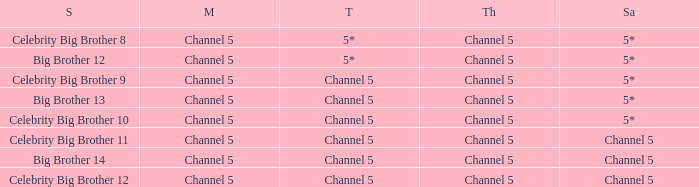Which Thursday does big brother 13 air? Channel 5. 